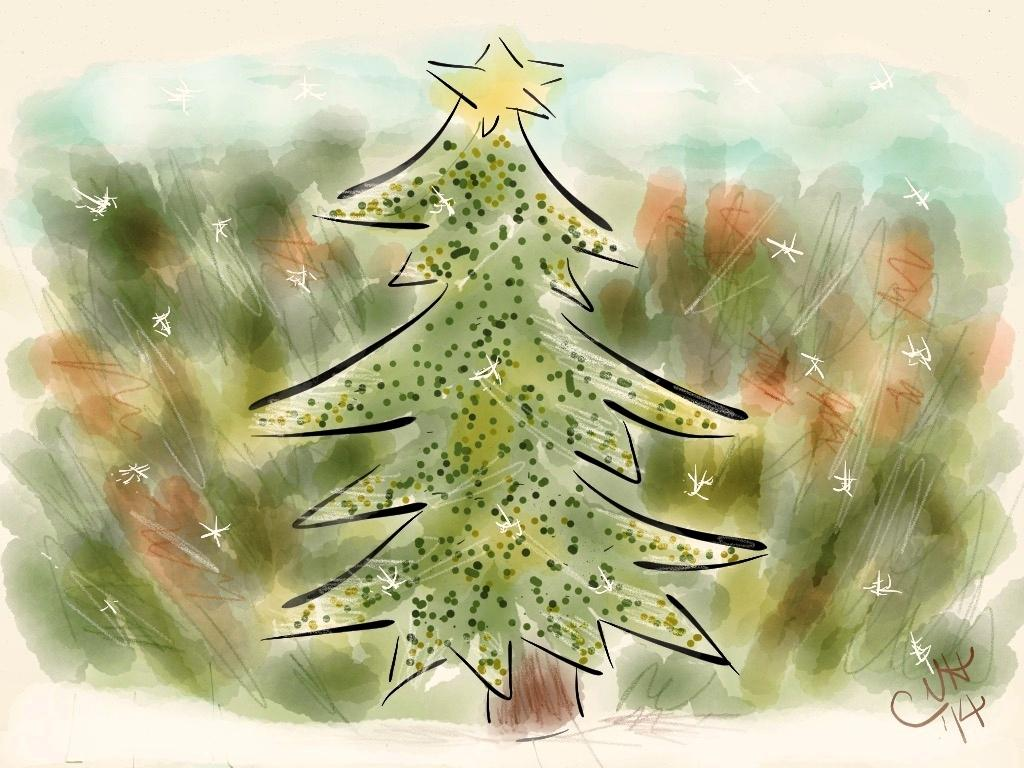What is the main object in the image? There is a tree in the image. What can be seen in the background of the image? The background of the image is greenery. How many cakes are on the tree in the image? There are no cakes present in the image; it features a tree and greenery. What type of behavior can be observed in the tree in the image? There is no behavior to observe in the tree, as it is a static object in the image. 